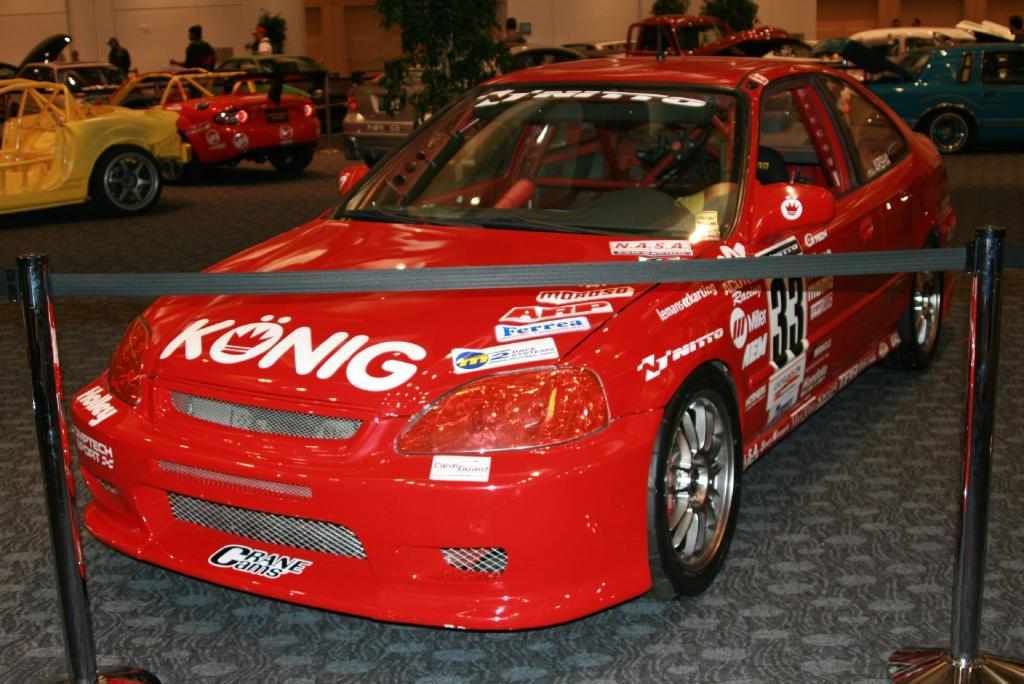What types of objects can be seen in the image? There are vehicles in the image. Can you describe one of the vehicles? One of the vehicles is red. What other objects are present in the image? There are two poles in the image. What can be seen in the background of the image? There are trees and buildings in the background of the image. How are the buildings colored? The buildings are white and cream in color. What type of furniture is being used by the boy in the image? There is no boy or furniture present in the image. How does the grip of the vehicle change throughout the image? The image does not show any changes in the grip of the vehicle, as it is a still image. 